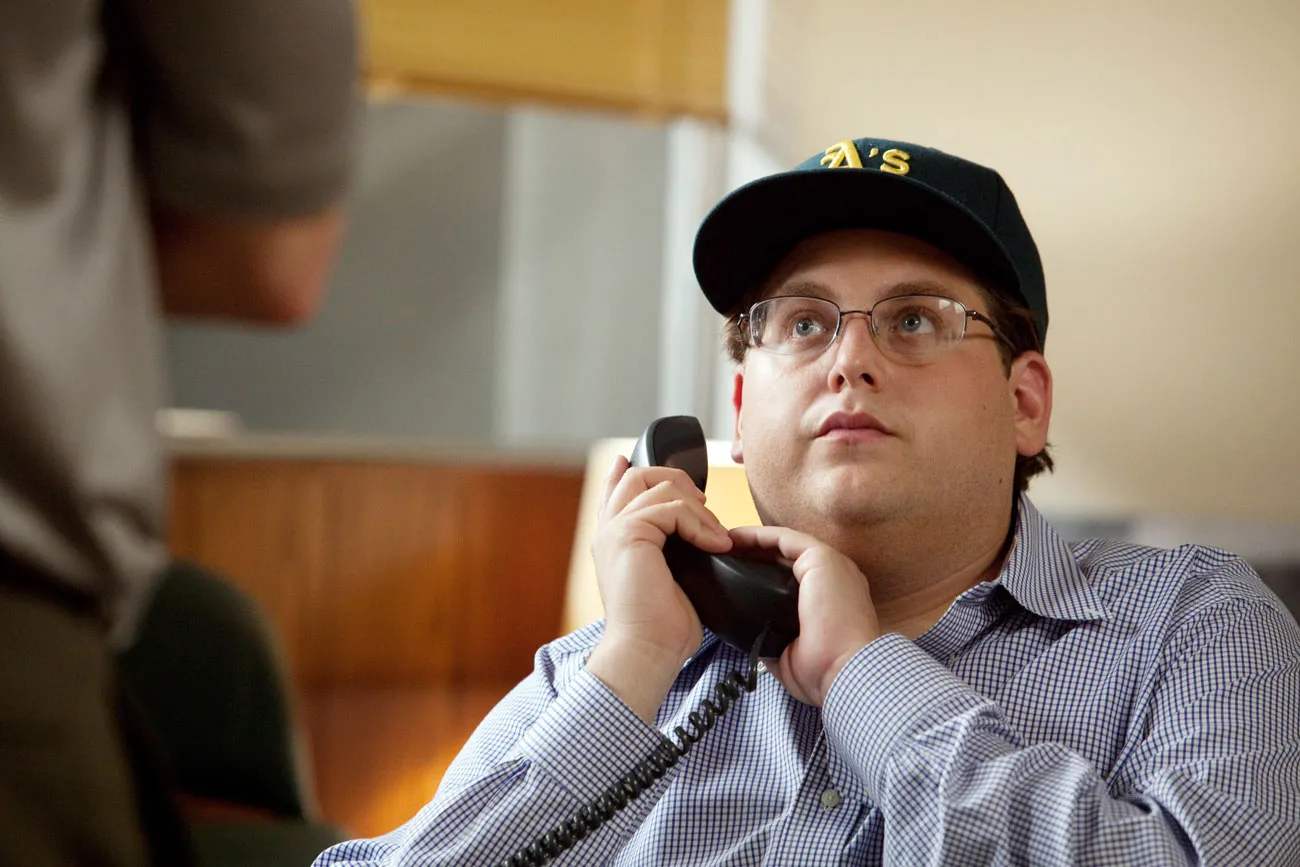How does the office setting impact the feeling of the image? The office setting, highlighted by indistinct background features like a blurred laptop and papers, contributes to a professional yet personal ambiance. It focuses our attention on the man's interaction with the phone, emphasizing the seriousness or immediacy of the conversation. The setting suggests a narrative where office workload and communication are central themes. 